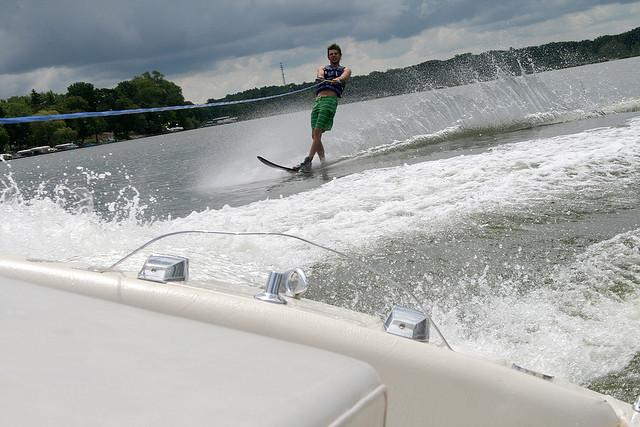What powers the vessel pulling the skier? motor 